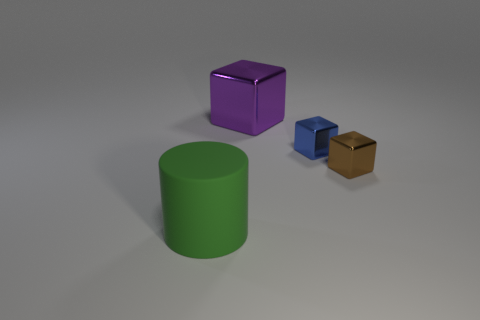How many big purple things are the same material as the brown block?
Your answer should be very brief. 1. What number of matte objects are either brown things or tiny objects?
Make the answer very short. 0. What material is the purple object that is the same size as the cylinder?
Offer a very short reply. Metal. Are there any large yellow blocks that have the same material as the brown object?
Keep it short and to the point. No. There is a large thing that is in front of the large thing on the right side of the big thing that is to the left of the large purple cube; what is its shape?
Keep it short and to the point. Cylinder. Do the green thing and the metal cube right of the small blue cube have the same size?
Provide a succinct answer. No. What is the shape of the thing that is behind the small brown metal thing and on the left side of the tiny blue block?
Offer a very short reply. Cube. How many small things are green rubber things or green balls?
Offer a terse response. 0. Are there the same number of big purple things left of the large green rubber cylinder and purple cubes that are to the right of the brown metallic cube?
Offer a terse response. Yes. How many other things are the same color as the big rubber cylinder?
Offer a very short reply. 0. 